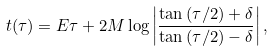<formula> <loc_0><loc_0><loc_500><loc_500>t ( \tau ) = E \tau + 2 M \log \left | \frac { \tan { ( \tau / 2 ) } + \delta } { \tan { ( \tau / 2 ) } - \delta } \right | ,</formula> 